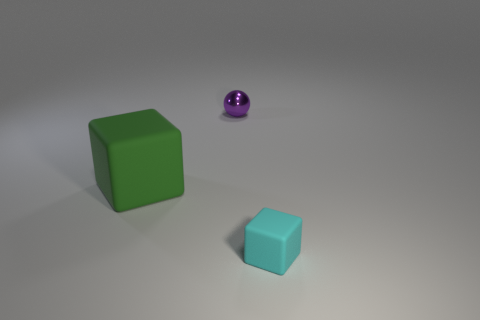What is the material of the small object that is in front of the block that is behind the small cyan block?
Make the answer very short. Rubber. Does the tiny object that is left of the small block have the same shape as the thing that is to the left of the small purple ball?
Offer a very short reply. No. Are there an equal number of purple spheres that are on the left side of the tiny sphere and brown metal cubes?
Make the answer very short. Yes. Is there a small purple thing that is right of the cube that is left of the cyan rubber thing?
Keep it short and to the point. Yes. Is there any other thing of the same color as the tiny metallic object?
Keep it short and to the point. No. Is the tiny object that is behind the green rubber cube made of the same material as the cyan thing?
Make the answer very short. No. Is the number of cyan rubber cubes behind the tiny matte thing the same as the number of matte things behind the large cube?
Your response must be concise. Yes. There is a matte block that is in front of the matte thing left of the ball; what is its size?
Provide a succinct answer. Small. There is a thing that is both in front of the tiny shiny sphere and behind the cyan rubber cube; what material is it?
Ensure brevity in your answer.  Rubber. How many other objects are there of the same size as the green thing?
Provide a short and direct response. 0. 